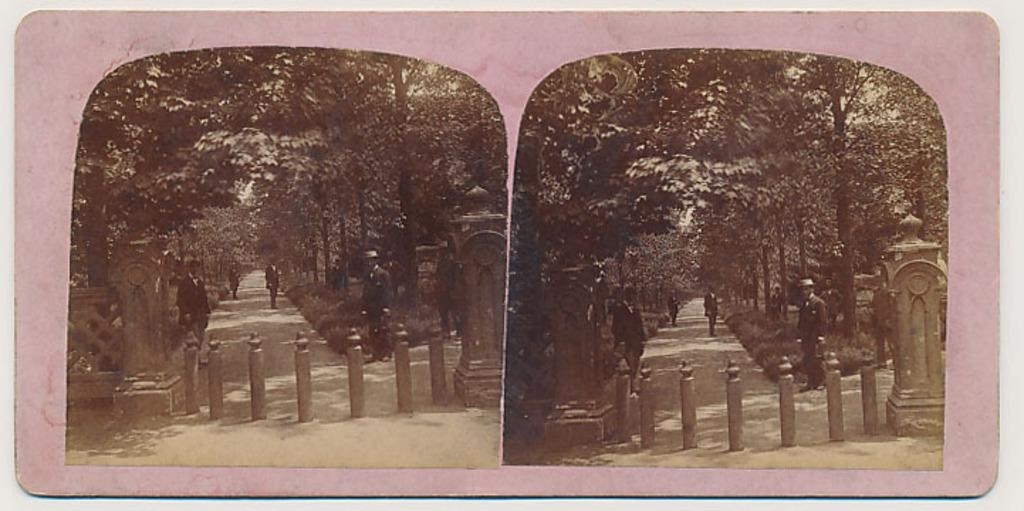What type of images can be seen in the picture? There are pictures of roads, people, and trees in the image. Can you describe the images of people in the picture? The images of people in the picture show various individuals. What other type of images are present in the picture? The picture also contains images of trees. What type of juice is being served in the image? There is no juice present in the image; it only contains pictures of roads, people, and trees. What disease is being treated in the image? There is no indication of any disease or treatment in the image; it only contains pictures of roads, people, and trees. 